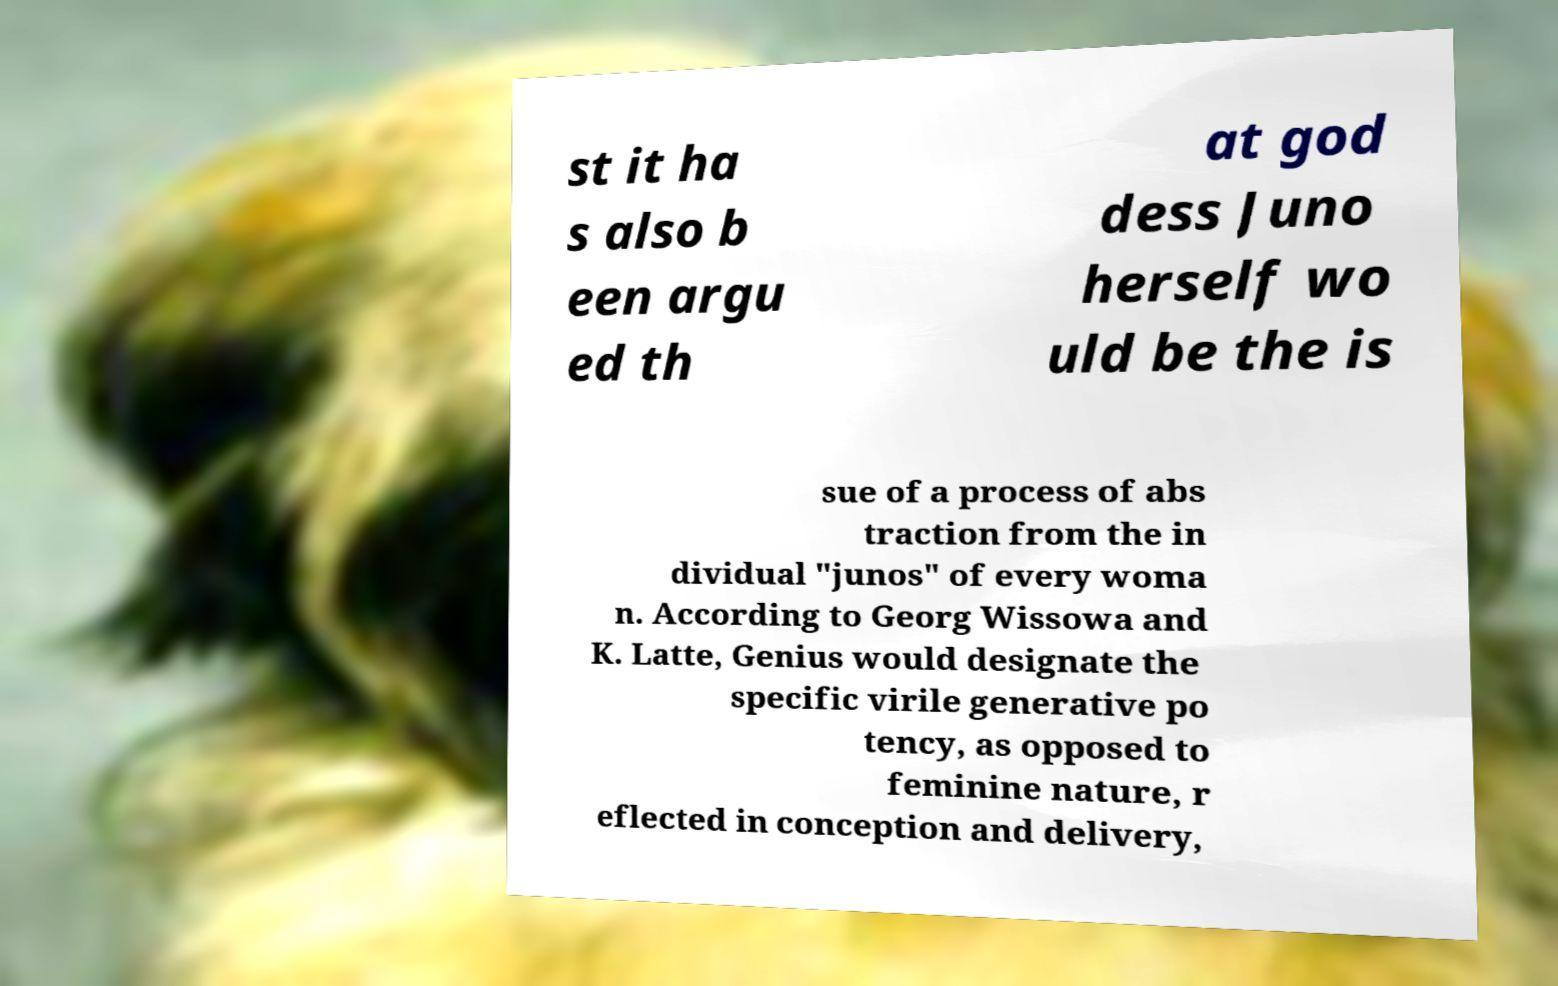There's text embedded in this image that I need extracted. Can you transcribe it verbatim? st it ha s also b een argu ed th at god dess Juno herself wo uld be the is sue of a process of abs traction from the in dividual "junos" of every woma n. According to Georg Wissowa and K. Latte, Genius would designate the specific virile generative po tency, as opposed to feminine nature, r eflected in conception and delivery, 